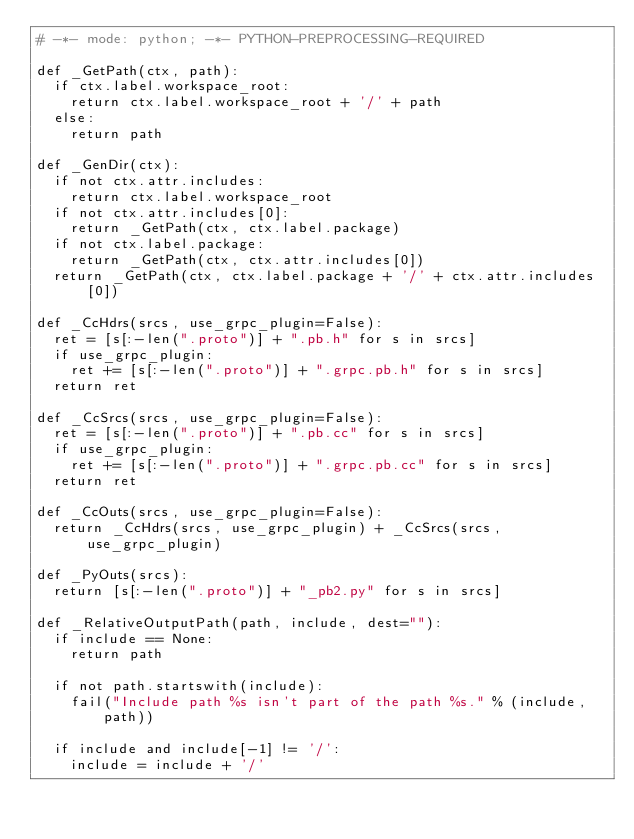<code> <loc_0><loc_0><loc_500><loc_500><_Python_># -*- mode: python; -*- PYTHON-PREPROCESSING-REQUIRED

def _GetPath(ctx, path):
  if ctx.label.workspace_root:
    return ctx.label.workspace_root + '/' + path
  else:
    return path

def _GenDir(ctx):
  if not ctx.attr.includes:
    return ctx.label.workspace_root
  if not ctx.attr.includes[0]:
    return _GetPath(ctx, ctx.label.package)
  if not ctx.label.package:
    return _GetPath(ctx, ctx.attr.includes[0])
  return _GetPath(ctx, ctx.label.package + '/' + ctx.attr.includes[0])

def _CcHdrs(srcs, use_grpc_plugin=False):
  ret = [s[:-len(".proto")] + ".pb.h" for s in srcs]
  if use_grpc_plugin:
    ret += [s[:-len(".proto")] + ".grpc.pb.h" for s in srcs]
  return ret

def _CcSrcs(srcs, use_grpc_plugin=False):
  ret = [s[:-len(".proto")] + ".pb.cc" for s in srcs]
  if use_grpc_plugin:
    ret += [s[:-len(".proto")] + ".grpc.pb.cc" for s in srcs]
  return ret

def _CcOuts(srcs, use_grpc_plugin=False):
  return _CcHdrs(srcs, use_grpc_plugin) + _CcSrcs(srcs, use_grpc_plugin)

def _PyOuts(srcs):
  return [s[:-len(".proto")] + "_pb2.py" for s in srcs]

def _RelativeOutputPath(path, include, dest=""):
  if include == None:
    return path

  if not path.startswith(include):
    fail("Include path %s isn't part of the path %s." % (include, path))

  if include and include[-1] != '/':
    include = include + '/'</code> 